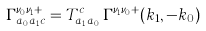<formula> <loc_0><loc_0><loc_500><loc_500>\Gamma _ { a _ { 0 } a _ { 1 } c } ^ { \nu _ { 0 } \nu _ { 1 } + } = T _ { a _ { 1 } a _ { 0 } } ^ { c } \, \Gamma ^ { \nu _ { 1 } \nu _ { 0 } + } ( k _ { 1 } , - k _ { 0 } ) \,</formula> 